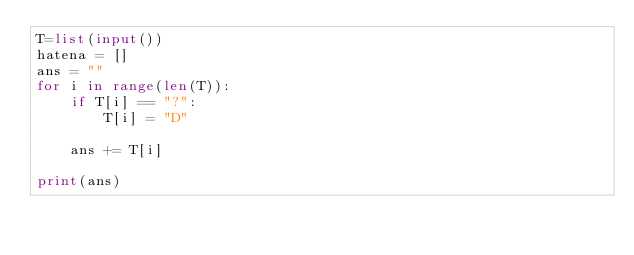<code> <loc_0><loc_0><loc_500><loc_500><_Python_>T=list(input())
hatena = []
ans = ""
for i in range(len(T)):
    if T[i] == "?":
        T[i] = "D"

    ans += T[i]

print(ans)</code> 